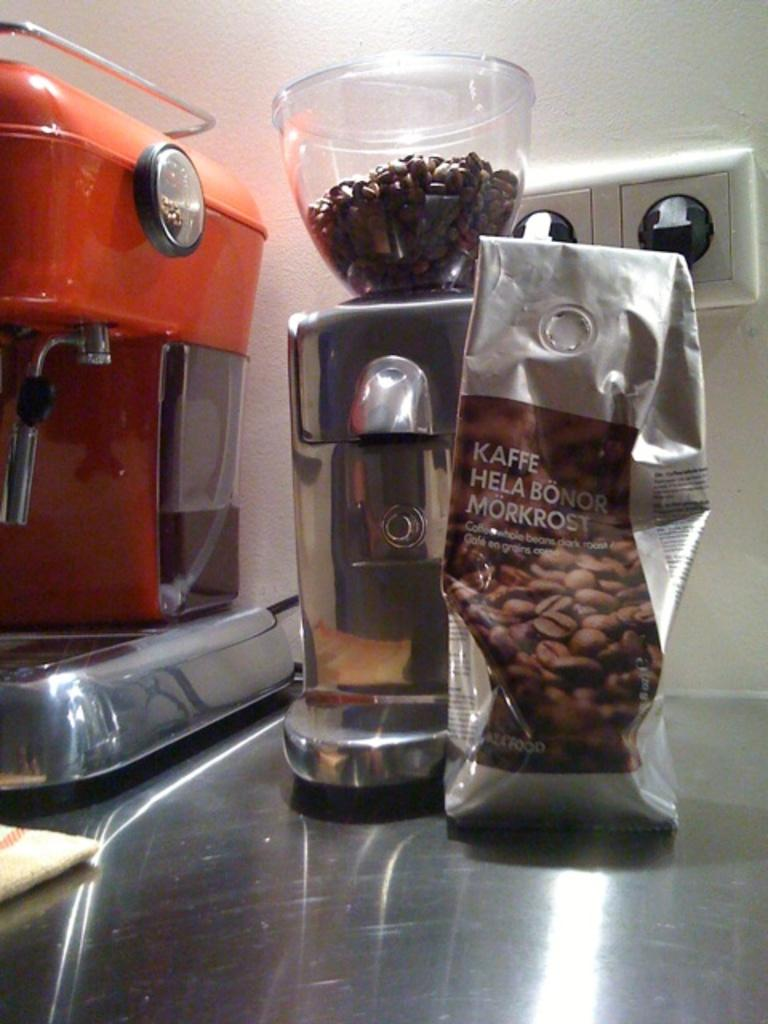Provide a one-sentence caption for the provided image. A bag of coffee beans that says Kaffe Hela Bonor Morkrost on the bag and a coffee grinder is beside the bag filled with coffee beans. 